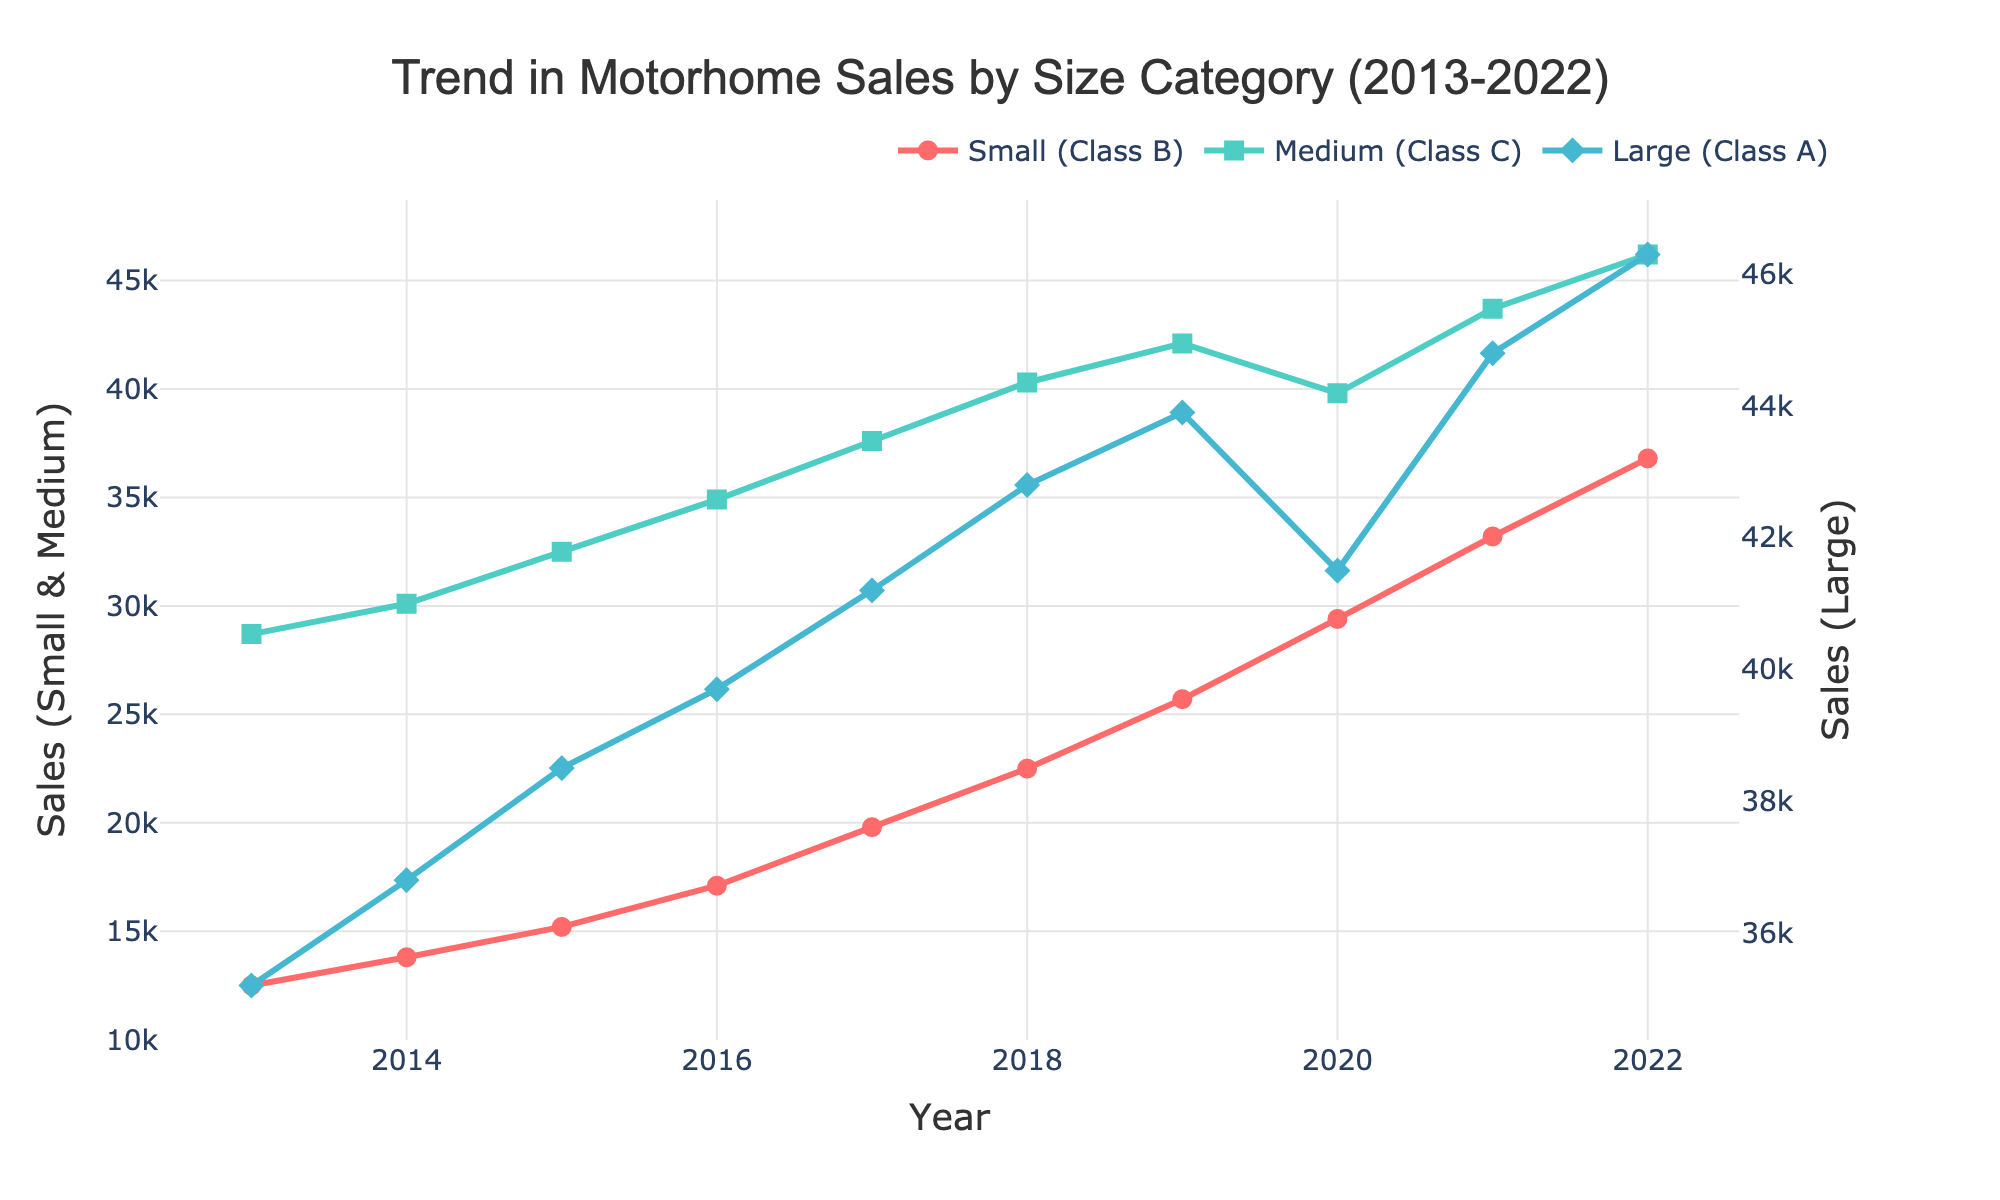What is the overall trend in motorhome sales for Small (Class B) from 2013 to 2022? The sales of Small (Class B) motorhomes show a consistent upward trend from 2013 to 2022. Starting at 12,500 units in 2013 and rising each year to 36,800 units by 2022.
Answer: Upward trend Between which two consecutive years did Medium (Class C) motorhomes see the highest increase in sales? To find the period with the highest increase in sales, we need to calculate the differences between consecutive years. The increase from 2015 to 2016 is 24900 - 22500 = 2400 units, which is the highest compared to other periods.
Answer: 2015 to 2016 Which category had the highest sales in 2019, and what was the sales figure? In 2019, the highest sales figure among the categories was for Medium (Class C) motorhomes at 42,100 units. This can be determined by comparing the sales figures for all three categories for that year.
Answer: Medium (Class C), 42,100 By how much did the sales of Large (Class A) motorhomes increase from 2013 to 2022? Sales of Large (Class A) motorhomes increased from 35,200 in 2013 to 46,300 in 2022. The increase is calculated as 46,300 - 35,200 = 11,100 units.
Answer: 11,100 Which year saw a decline in sales for Small (Class B) motorhomes? Observing the trend, the sales of Small (Class B) motorhomes show a consistent increase every year with no declines. Hence, there is no year with a decline in sales for this category from 2013 to 2022.
Answer: No decline Did any category experience a sales dip in 2020 compared to 2019? If so, which one and by how much? Both Small (Class B) and Large (Class A) categories show a dip in sales in 2020 compared to 2019. Small (Class B) went from 25,700 in 2019 to 29,400 in 2020 (+3,700 units), while Large (Class A) declined from 43,900 in 2019 to 41,500 in 2020 (-2,400 units).
Answer: Large (Class A), 2,400 How did the sales growth for Medium (Class C) motorhomes between 2020 and 2021 compare to the sales growth between 2021 and 2022? Sales growth between 2020 and 2021 was 43,700 - 39,800 = 3,900 units. The growth between 2021 and 2022 was 46,200 - 43,700 = 2,500 units. Comparing these, the growth was higher between 2020 and 2021.
Answer: 3,900 vs 2,500 What is the average annual sales of Medium (Class C) motorhomes over the ten-year period? Adding the annual sales for Medium (Class C) from 2013 to 2022, we get a total of 3,561,500 units. Dividing by 10 years, the average annual sales is 3,561,500 / 10 = 35,615 units.
Answer: 35,615 units In which year did the sales for Large (Class A) motorhomes exceed 40,000 units for the first time? The sales of Large (Class A) motorhomes first exceeded 40,000 units in 2016, with sales of 39,700 units. Sales were 37,600 units in 2015, which then increased in 2016.
Answer: 2016 Comparing the years 2017 and 2022, which category saw the greatest absolute increase in sales, and what was the value of the increase? In 2017, Small (Class B) sales were 19,800 units, and in 2022, it was 36,800 units, an increase of 17,000 units. For Medium (Class C), 37,600 to 46,200 is an increase of 8,600 units. For Large (Class A), 41,200 to 46,300 is an increase of 5,100 units. The greatest absolute increase is for Small (Class B) with 17,000 units.
Answer: Small (Class B), 17,000 units 